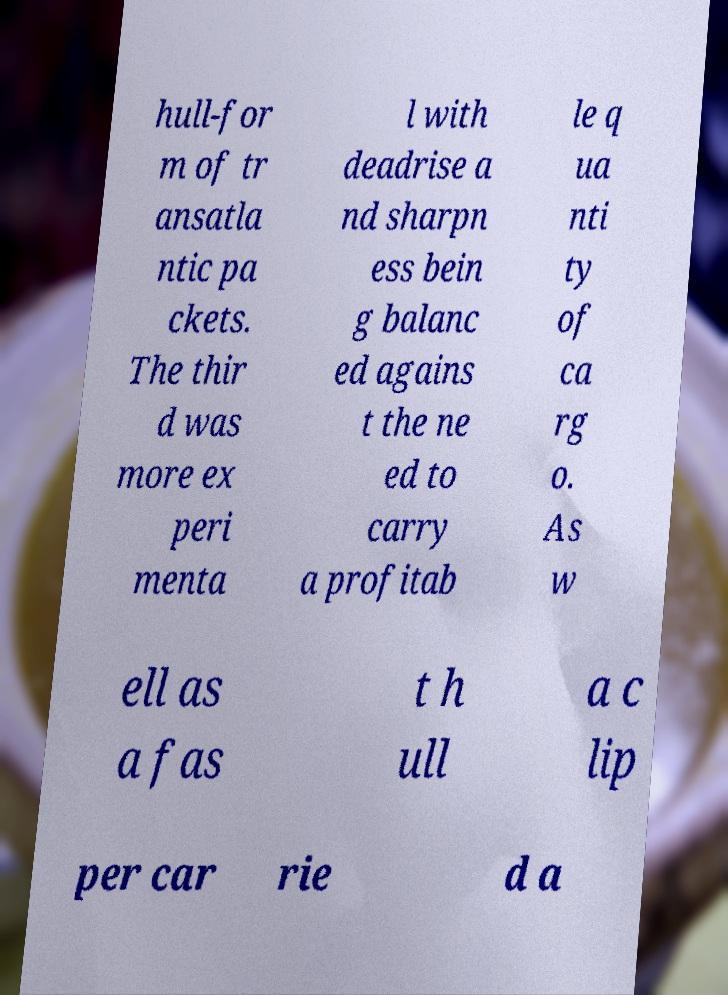Please read and relay the text visible in this image. What does it say? hull-for m of tr ansatla ntic pa ckets. The thir d was more ex peri menta l with deadrise a nd sharpn ess bein g balanc ed agains t the ne ed to carry a profitab le q ua nti ty of ca rg o. As w ell as a fas t h ull a c lip per car rie d a 